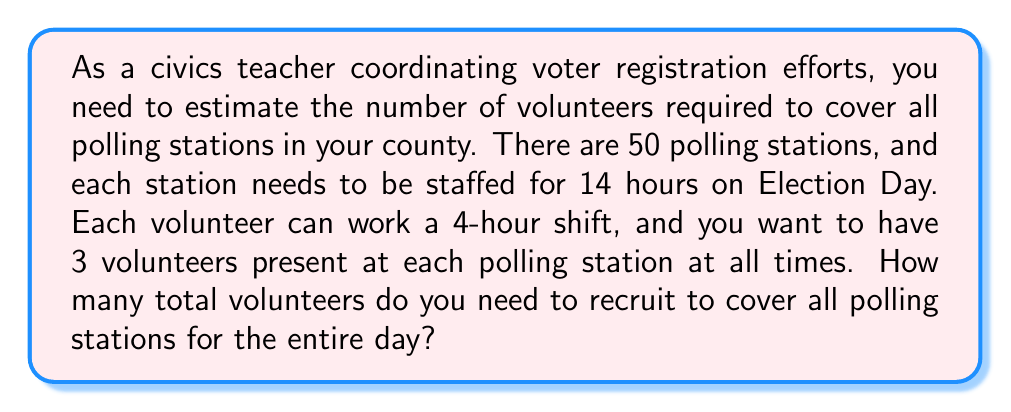Give your solution to this math problem. Let's break this problem down step-by-step:

1. Calculate the number of volunteer-hours needed per polling station:
   $$ \text{Hours per day} \times \text{Volunteers per station} = 14 \times 3 = 42 \text{ volunteer-hours} $$

2. Calculate the total volunteer-hours needed for all polling stations:
   $$ \text{Volunteer-hours per station} \times \text{Number of stations} = 42 \times 50 = 2100 \text{ total volunteer-hours} $$

3. Calculate how many 4-hour shifts one volunteer can cover:
   $$ \text{Shifts per volunteer} = \frac{\text{Hours per day}}{\text{Hours per shift}} = \frac{14}{4} = 3.5 \text{ shifts} $$
   However, we can't assign partial shifts, so each volunteer can cover 3 full shifts.

4. Calculate the number of volunteer-hours one person can cover:
   $$ \text{Volunteer-hours per person} = \text{Hours per shift} \times \text{Shifts per volunteer} = 4 \times 3 = 12 \text{ hours} $$

5. Calculate the total number of volunteers needed:
   $$ \text{Total volunteers} = \frac{\text{Total volunteer-hours needed}}{\text{Volunteer-hours per person}} = \frac{2100}{12} = 175 \text{ volunteers} $$

Therefore, you need to recruit 175 volunteers to cover all polling stations for the entire Election Day.
Answer: 175 volunteers 